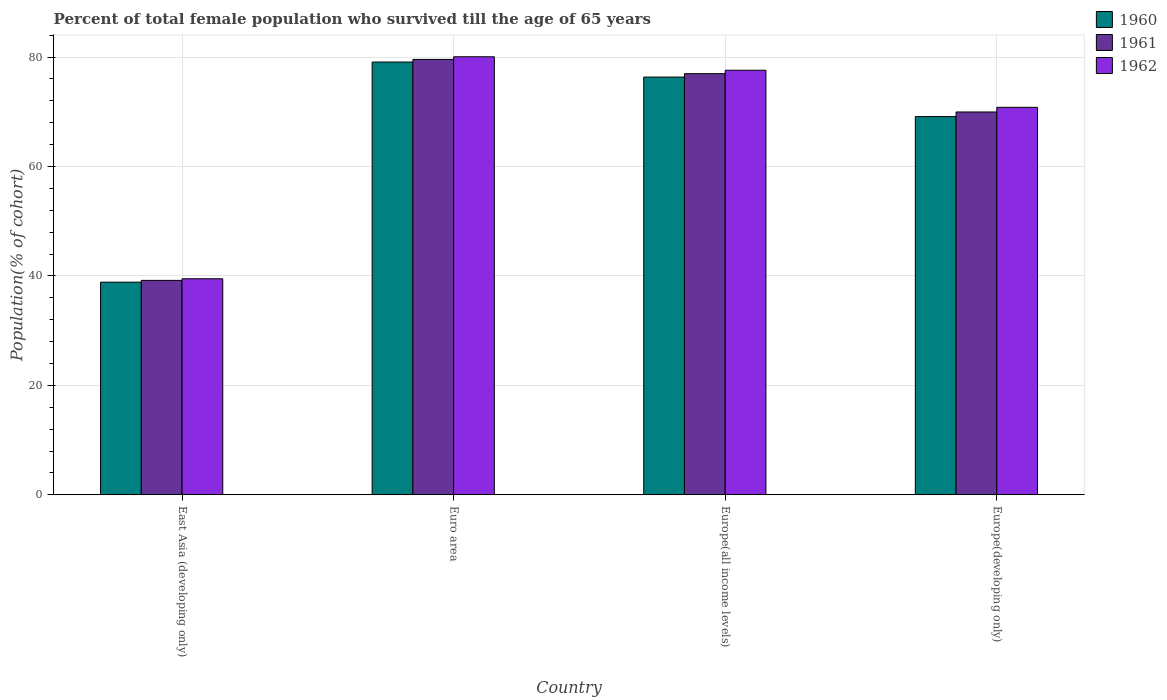Are the number of bars on each tick of the X-axis equal?
Your answer should be very brief. Yes. What is the label of the 3rd group of bars from the left?
Your answer should be compact. Europe(all income levels). What is the percentage of total female population who survived till the age of 65 years in 1961 in Europe(all income levels)?
Give a very brief answer. 76.97. Across all countries, what is the maximum percentage of total female population who survived till the age of 65 years in 1961?
Offer a very short reply. 79.57. Across all countries, what is the minimum percentage of total female population who survived till the age of 65 years in 1962?
Your answer should be compact. 39.48. In which country was the percentage of total female population who survived till the age of 65 years in 1961 maximum?
Give a very brief answer. Euro area. In which country was the percentage of total female population who survived till the age of 65 years in 1960 minimum?
Keep it short and to the point. East Asia (developing only). What is the total percentage of total female population who survived till the age of 65 years in 1961 in the graph?
Offer a terse response. 265.69. What is the difference between the percentage of total female population who survived till the age of 65 years in 1960 in Euro area and that in Europe(all income levels)?
Offer a terse response. 2.75. What is the difference between the percentage of total female population who survived till the age of 65 years in 1962 in Europe(developing only) and the percentage of total female population who survived till the age of 65 years in 1960 in Europe(all income levels)?
Offer a terse response. -5.53. What is the average percentage of total female population who survived till the age of 65 years in 1960 per country?
Make the answer very short. 65.85. What is the difference between the percentage of total female population who survived till the age of 65 years of/in 1962 and percentage of total female population who survived till the age of 65 years of/in 1961 in Euro area?
Your answer should be very brief. 0.48. In how many countries, is the percentage of total female population who survived till the age of 65 years in 1961 greater than 28 %?
Make the answer very short. 4. What is the ratio of the percentage of total female population who survived till the age of 65 years in 1961 in East Asia (developing only) to that in Euro area?
Make the answer very short. 0.49. What is the difference between the highest and the second highest percentage of total female population who survived till the age of 65 years in 1961?
Give a very brief answer. 7. What is the difference between the highest and the lowest percentage of total female population who survived till the age of 65 years in 1960?
Your answer should be very brief. 40.23. Is it the case that in every country, the sum of the percentage of total female population who survived till the age of 65 years in 1960 and percentage of total female population who survived till the age of 65 years in 1961 is greater than the percentage of total female population who survived till the age of 65 years in 1962?
Make the answer very short. Yes. How many bars are there?
Keep it short and to the point. 12. Does the graph contain any zero values?
Provide a short and direct response. No. Does the graph contain grids?
Offer a very short reply. Yes. How many legend labels are there?
Make the answer very short. 3. What is the title of the graph?
Keep it short and to the point. Percent of total female population who survived till the age of 65 years. Does "1999" appear as one of the legend labels in the graph?
Your response must be concise. No. What is the label or title of the X-axis?
Your answer should be compact. Country. What is the label or title of the Y-axis?
Provide a succinct answer. Population(% of cohort). What is the Population(% of cohort) in 1960 in East Asia (developing only)?
Provide a short and direct response. 38.86. What is the Population(% of cohort) in 1961 in East Asia (developing only)?
Ensure brevity in your answer.  39.19. What is the Population(% of cohort) in 1962 in East Asia (developing only)?
Offer a terse response. 39.48. What is the Population(% of cohort) in 1960 in Euro area?
Provide a succinct answer. 79.09. What is the Population(% of cohort) in 1961 in Euro area?
Your answer should be compact. 79.57. What is the Population(% of cohort) of 1962 in Euro area?
Provide a succinct answer. 80.06. What is the Population(% of cohort) in 1960 in Europe(all income levels)?
Your answer should be very brief. 76.34. What is the Population(% of cohort) of 1961 in Europe(all income levels)?
Keep it short and to the point. 76.97. What is the Population(% of cohort) in 1962 in Europe(all income levels)?
Make the answer very short. 77.6. What is the Population(% of cohort) of 1960 in Europe(developing only)?
Offer a very short reply. 69.12. What is the Population(% of cohort) in 1961 in Europe(developing only)?
Your response must be concise. 69.97. What is the Population(% of cohort) in 1962 in Europe(developing only)?
Your answer should be compact. 70.82. Across all countries, what is the maximum Population(% of cohort) of 1960?
Provide a succinct answer. 79.09. Across all countries, what is the maximum Population(% of cohort) in 1961?
Your response must be concise. 79.57. Across all countries, what is the maximum Population(% of cohort) of 1962?
Make the answer very short. 80.06. Across all countries, what is the minimum Population(% of cohort) in 1960?
Ensure brevity in your answer.  38.86. Across all countries, what is the minimum Population(% of cohort) in 1961?
Provide a short and direct response. 39.19. Across all countries, what is the minimum Population(% of cohort) of 1962?
Your answer should be very brief. 39.48. What is the total Population(% of cohort) of 1960 in the graph?
Offer a terse response. 263.42. What is the total Population(% of cohort) in 1961 in the graph?
Offer a terse response. 265.69. What is the total Population(% of cohort) in 1962 in the graph?
Make the answer very short. 267.95. What is the difference between the Population(% of cohort) in 1960 in East Asia (developing only) and that in Euro area?
Provide a short and direct response. -40.23. What is the difference between the Population(% of cohort) in 1961 in East Asia (developing only) and that in Euro area?
Your answer should be compact. -40.38. What is the difference between the Population(% of cohort) in 1962 in East Asia (developing only) and that in Euro area?
Offer a terse response. -40.57. What is the difference between the Population(% of cohort) of 1960 in East Asia (developing only) and that in Europe(all income levels)?
Provide a succinct answer. -37.48. What is the difference between the Population(% of cohort) of 1961 in East Asia (developing only) and that in Europe(all income levels)?
Your answer should be compact. -37.78. What is the difference between the Population(% of cohort) of 1962 in East Asia (developing only) and that in Europe(all income levels)?
Give a very brief answer. -38.12. What is the difference between the Population(% of cohort) of 1960 in East Asia (developing only) and that in Europe(developing only)?
Your answer should be compact. -30.26. What is the difference between the Population(% of cohort) of 1961 in East Asia (developing only) and that in Europe(developing only)?
Give a very brief answer. -30.78. What is the difference between the Population(% of cohort) of 1962 in East Asia (developing only) and that in Europe(developing only)?
Ensure brevity in your answer.  -31.34. What is the difference between the Population(% of cohort) in 1960 in Euro area and that in Europe(all income levels)?
Provide a succinct answer. 2.75. What is the difference between the Population(% of cohort) of 1961 in Euro area and that in Europe(all income levels)?
Your answer should be compact. 2.61. What is the difference between the Population(% of cohort) of 1962 in Euro area and that in Europe(all income levels)?
Ensure brevity in your answer.  2.46. What is the difference between the Population(% of cohort) in 1960 in Euro area and that in Europe(developing only)?
Give a very brief answer. 9.97. What is the difference between the Population(% of cohort) of 1961 in Euro area and that in Europe(developing only)?
Provide a short and direct response. 9.61. What is the difference between the Population(% of cohort) of 1962 in Euro area and that in Europe(developing only)?
Ensure brevity in your answer.  9.24. What is the difference between the Population(% of cohort) in 1960 in Europe(all income levels) and that in Europe(developing only)?
Give a very brief answer. 7.22. What is the difference between the Population(% of cohort) in 1961 in Europe(all income levels) and that in Europe(developing only)?
Provide a short and direct response. 7. What is the difference between the Population(% of cohort) of 1962 in Europe(all income levels) and that in Europe(developing only)?
Keep it short and to the point. 6.78. What is the difference between the Population(% of cohort) in 1960 in East Asia (developing only) and the Population(% of cohort) in 1961 in Euro area?
Provide a short and direct response. -40.71. What is the difference between the Population(% of cohort) in 1960 in East Asia (developing only) and the Population(% of cohort) in 1962 in Euro area?
Your answer should be very brief. -41.19. What is the difference between the Population(% of cohort) in 1961 in East Asia (developing only) and the Population(% of cohort) in 1962 in Euro area?
Offer a very short reply. -40.87. What is the difference between the Population(% of cohort) of 1960 in East Asia (developing only) and the Population(% of cohort) of 1961 in Europe(all income levels)?
Give a very brief answer. -38.1. What is the difference between the Population(% of cohort) of 1960 in East Asia (developing only) and the Population(% of cohort) of 1962 in Europe(all income levels)?
Offer a terse response. -38.73. What is the difference between the Population(% of cohort) in 1961 in East Asia (developing only) and the Population(% of cohort) in 1962 in Europe(all income levels)?
Your answer should be compact. -38.41. What is the difference between the Population(% of cohort) in 1960 in East Asia (developing only) and the Population(% of cohort) in 1961 in Europe(developing only)?
Your response must be concise. -31.1. What is the difference between the Population(% of cohort) of 1960 in East Asia (developing only) and the Population(% of cohort) of 1962 in Europe(developing only)?
Offer a very short reply. -31.95. What is the difference between the Population(% of cohort) of 1961 in East Asia (developing only) and the Population(% of cohort) of 1962 in Europe(developing only)?
Your answer should be compact. -31.63. What is the difference between the Population(% of cohort) in 1960 in Euro area and the Population(% of cohort) in 1961 in Europe(all income levels)?
Ensure brevity in your answer.  2.12. What is the difference between the Population(% of cohort) of 1960 in Euro area and the Population(% of cohort) of 1962 in Europe(all income levels)?
Make the answer very short. 1.49. What is the difference between the Population(% of cohort) in 1961 in Euro area and the Population(% of cohort) in 1962 in Europe(all income levels)?
Your answer should be very brief. 1.97. What is the difference between the Population(% of cohort) in 1960 in Euro area and the Population(% of cohort) in 1961 in Europe(developing only)?
Ensure brevity in your answer.  9.12. What is the difference between the Population(% of cohort) of 1960 in Euro area and the Population(% of cohort) of 1962 in Europe(developing only)?
Give a very brief answer. 8.27. What is the difference between the Population(% of cohort) in 1961 in Euro area and the Population(% of cohort) in 1962 in Europe(developing only)?
Provide a short and direct response. 8.76. What is the difference between the Population(% of cohort) in 1960 in Europe(all income levels) and the Population(% of cohort) in 1961 in Europe(developing only)?
Offer a very short reply. 6.38. What is the difference between the Population(% of cohort) in 1960 in Europe(all income levels) and the Population(% of cohort) in 1962 in Europe(developing only)?
Give a very brief answer. 5.53. What is the difference between the Population(% of cohort) in 1961 in Europe(all income levels) and the Population(% of cohort) in 1962 in Europe(developing only)?
Your answer should be very brief. 6.15. What is the average Population(% of cohort) of 1960 per country?
Offer a terse response. 65.85. What is the average Population(% of cohort) in 1961 per country?
Give a very brief answer. 66.42. What is the average Population(% of cohort) of 1962 per country?
Give a very brief answer. 66.99. What is the difference between the Population(% of cohort) in 1960 and Population(% of cohort) in 1961 in East Asia (developing only)?
Offer a very short reply. -0.33. What is the difference between the Population(% of cohort) in 1960 and Population(% of cohort) in 1962 in East Asia (developing only)?
Ensure brevity in your answer.  -0.62. What is the difference between the Population(% of cohort) in 1961 and Population(% of cohort) in 1962 in East Asia (developing only)?
Your answer should be very brief. -0.29. What is the difference between the Population(% of cohort) of 1960 and Population(% of cohort) of 1961 in Euro area?
Provide a succinct answer. -0.48. What is the difference between the Population(% of cohort) of 1960 and Population(% of cohort) of 1962 in Euro area?
Provide a succinct answer. -0.97. What is the difference between the Population(% of cohort) of 1961 and Population(% of cohort) of 1962 in Euro area?
Provide a short and direct response. -0.48. What is the difference between the Population(% of cohort) of 1960 and Population(% of cohort) of 1961 in Europe(all income levels)?
Provide a succinct answer. -0.62. What is the difference between the Population(% of cohort) in 1960 and Population(% of cohort) in 1962 in Europe(all income levels)?
Keep it short and to the point. -1.25. What is the difference between the Population(% of cohort) of 1961 and Population(% of cohort) of 1962 in Europe(all income levels)?
Offer a terse response. -0.63. What is the difference between the Population(% of cohort) in 1960 and Population(% of cohort) in 1961 in Europe(developing only)?
Give a very brief answer. -0.84. What is the difference between the Population(% of cohort) of 1960 and Population(% of cohort) of 1962 in Europe(developing only)?
Give a very brief answer. -1.69. What is the difference between the Population(% of cohort) of 1961 and Population(% of cohort) of 1962 in Europe(developing only)?
Keep it short and to the point. -0.85. What is the ratio of the Population(% of cohort) of 1960 in East Asia (developing only) to that in Euro area?
Your answer should be compact. 0.49. What is the ratio of the Population(% of cohort) of 1961 in East Asia (developing only) to that in Euro area?
Your response must be concise. 0.49. What is the ratio of the Population(% of cohort) of 1962 in East Asia (developing only) to that in Euro area?
Offer a very short reply. 0.49. What is the ratio of the Population(% of cohort) of 1960 in East Asia (developing only) to that in Europe(all income levels)?
Your response must be concise. 0.51. What is the ratio of the Population(% of cohort) in 1961 in East Asia (developing only) to that in Europe(all income levels)?
Your answer should be compact. 0.51. What is the ratio of the Population(% of cohort) of 1962 in East Asia (developing only) to that in Europe(all income levels)?
Give a very brief answer. 0.51. What is the ratio of the Population(% of cohort) of 1960 in East Asia (developing only) to that in Europe(developing only)?
Give a very brief answer. 0.56. What is the ratio of the Population(% of cohort) in 1961 in East Asia (developing only) to that in Europe(developing only)?
Provide a short and direct response. 0.56. What is the ratio of the Population(% of cohort) of 1962 in East Asia (developing only) to that in Europe(developing only)?
Provide a succinct answer. 0.56. What is the ratio of the Population(% of cohort) of 1960 in Euro area to that in Europe(all income levels)?
Keep it short and to the point. 1.04. What is the ratio of the Population(% of cohort) in 1961 in Euro area to that in Europe(all income levels)?
Offer a terse response. 1.03. What is the ratio of the Population(% of cohort) of 1962 in Euro area to that in Europe(all income levels)?
Your answer should be compact. 1.03. What is the ratio of the Population(% of cohort) of 1960 in Euro area to that in Europe(developing only)?
Your response must be concise. 1.14. What is the ratio of the Population(% of cohort) of 1961 in Euro area to that in Europe(developing only)?
Provide a succinct answer. 1.14. What is the ratio of the Population(% of cohort) of 1962 in Euro area to that in Europe(developing only)?
Make the answer very short. 1.13. What is the ratio of the Population(% of cohort) in 1960 in Europe(all income levels) to that in Europe(developing only)?
Offer a terse response. 1.1. What is the ratio of the Population(% of cohort) of 1961 in Europe(all income levels) to that in Europe(developing only)?
Provide a succinct answer. 1.1. What is the ratio of the Population(% of cohort) of 1962 in Europe(all income levels) to that in Europe(developing only)?
Keep it short and to the point. 1.1. What is the difference between the highest and the second highest Population(% of cohort) of 1960?
Your answer should be very brief. 2.75. What is the difference between the highest and the second highest Population(% of cohort) in 1961?
Offer a terse response. 2.61. What is the difference between the highest and the second highest Population(% of cohort) in 1962?
Offer a terse response. 2.46. What is the difference between the highest and the lowest Population(% of cohort) in 1960?
Offer a terse response. 40.23. What is the difference between the highest and the lowest Population(% of cohort) of 1961?
Offer a very short reply. 40.38. What is the difference between the highest and the lowest Population(% of cohort) of 1962?
Provide a short and direct response. 40.57. 